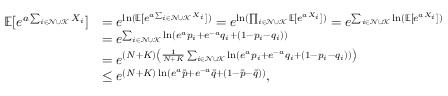<formula> <loc_0><loc_0><loc_500><loc_500>\begin{array} { r l } { \mathbb { E } [ e ^ { a \sum _ { i \in \mathcal { N } \cup \mathcal { K } } X _ { i } } ] } & { = e ^ { \ln ( \mathbb { E } [ e ^ { a \sum _ { i \in \mathcal { N } \cup \mathcal { K } } X _ { i } } ] ) } = e ^ { \ln ( \prod _ { i \in \mathcal { N } \cup \mathcal { K } } \mathbb { E } [ e ^ { a X _ { i } } ] ) } = e ^ { \sum _ { i \in \mathcal { N } \cup \mathcal { K } } \ln ( \mathbb { E } [ e ^ { a X _ { i } } ] ) } } \\ & { = e ^ { \sum _ { i \in \mathcal { N } \cup \mathcal { K } } \ln ( e ^ { a } p _ { i } + e ^ { - a } q _ { i } + ( 1 - p _ { i } - q _ { i } ) ) } } \\ & { = e ^ { ( N + K ) \left ( \frac { 1 } { N + K } \sum _ { i \in \mathcal { N } \cup \mathcal { K } } \ln ( e ^ { a } p _ { i } + e ^ { - a } q _ { i } + ( 1 - p _ { i } - q _ { i } ) ) \right ) } } \\ & { \leq e ^ { ( N + K ) \ln ( e ^ { a } \ B a r { p } + e ^ { - a } \ B a r { q } + ( 1 - \ B a r { p } - \ B a r { q } ) ) } , } \end{array}</formula> 